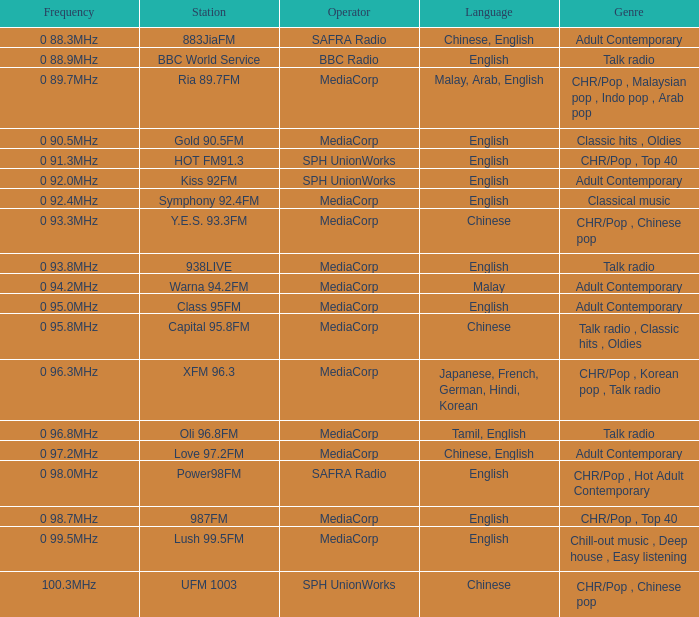What genre has a station of Class 95FM? Adult Contemporary. 